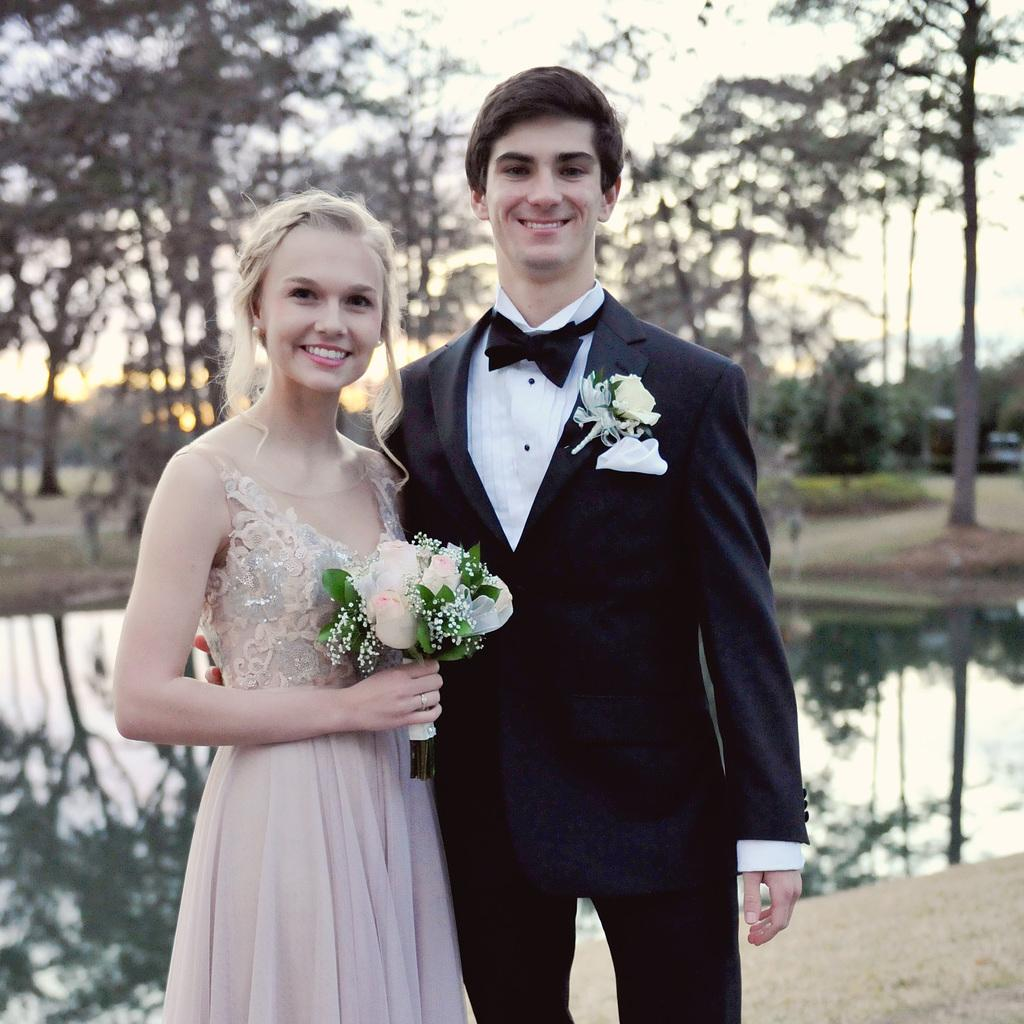What are the two people in the image doing? The man and woman are both standing in the image. The woman is holding a bouquet and smiling. What is the woman holding in the image? The woman is holding a bouquet in the image. What can be seen in the background of the image? In the background of the image, there is water, trees, the ground, and the sky visible. What type of wood is the egg made of in the image? There is no egg or wood present in the image. 